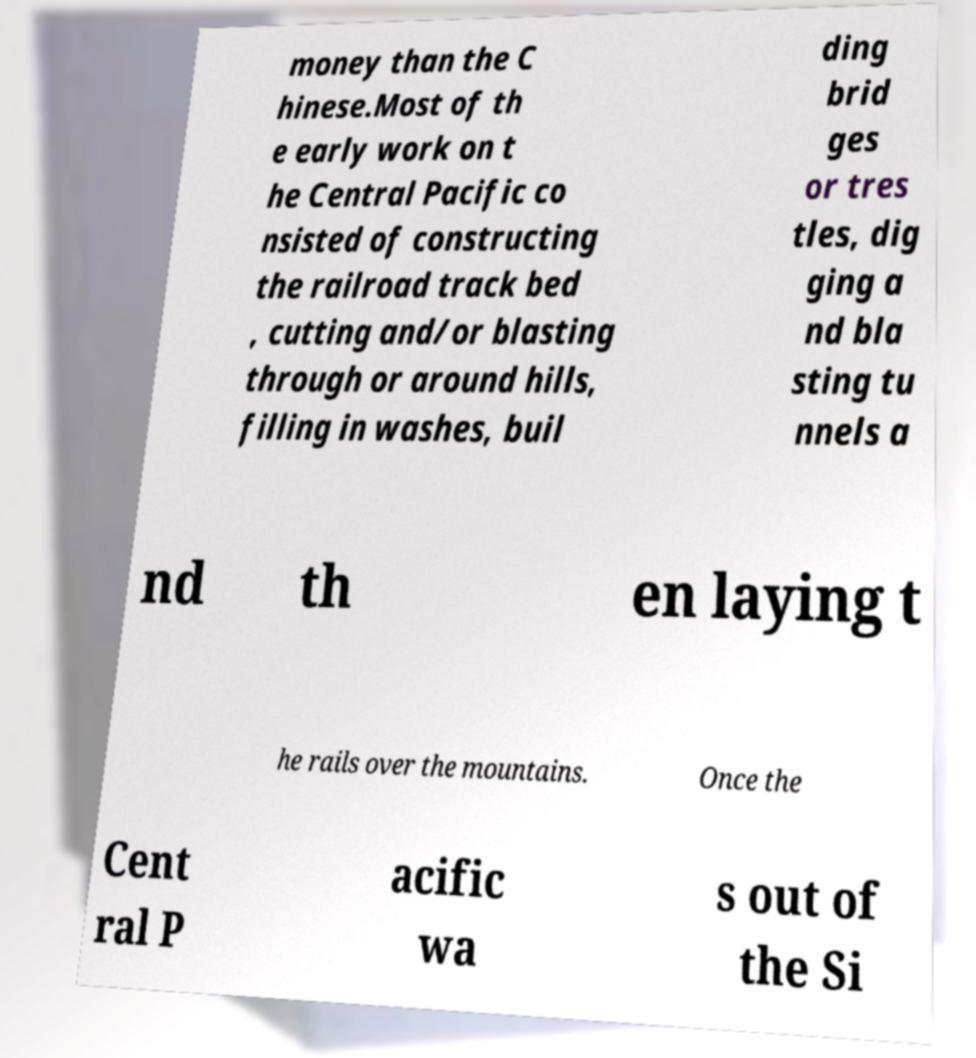Please identify and transcribe the text found in this image. money than the C hinese.Most of th e early work on t he Central Pacific co nsisted of constructing the railroad track bed , cutting and/or blasting through or around hills, filling in washes, buil ding brid ges or tres tles, dig ging a nd bla sting tu nnels a nd th en laying t he rails over the mountains. Once the Cent ral P acific wa s out of the Si 